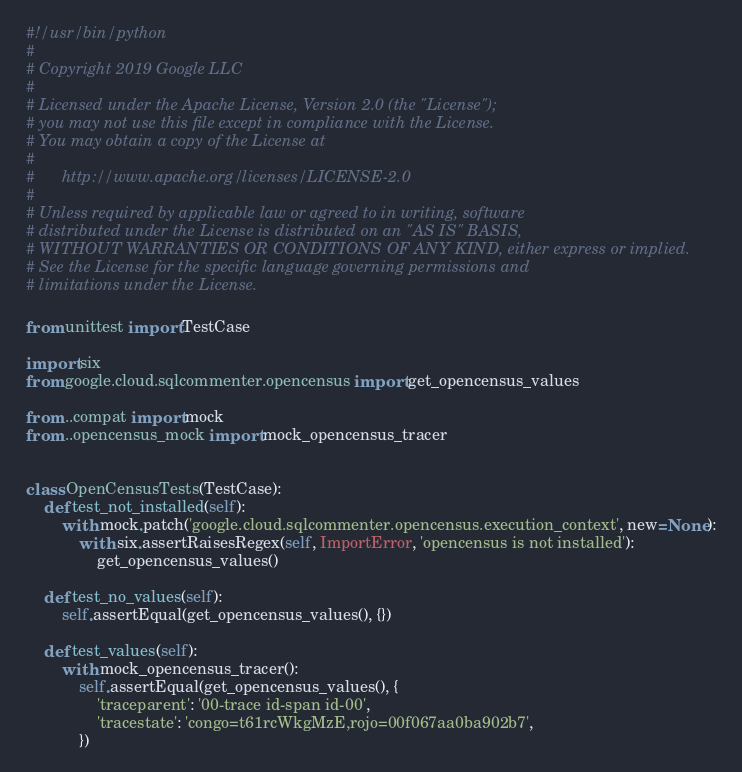<code> <loc_0><loc_0><loc_500><loc_500><_Python_>#!/usr/bin/python
#
# Copyright 2019 Google LLC
#
# Licensed under the Apache License, Version 2.0 (the "License");
# you may not use this file except in compliance with the License.
# You may obtain a copy of the License at
#
#      http://www.apache.org/licenses/LICENSE-2.0
#
# Unless required by applicable law or agreed to in writing, software
# distributed under the License is distributed on an "AS IS" BASIS,
# WITHOUT WARRANTIES OR CONDITIONS OF ANY KIND, either express or implied.
# See the License for the specific language governing permissions and
# limitations under the License.

from unittest import TestCase

import six
from google.cloud.sqlcommenter.opencensus import get_opencensus_values

from ..compat import mock
from ..opencensus_mock import mock_opencensus_tracer


class OpenCensusTests(TestCase):
    def test_not_installed(self):
        with mock.patch('google.cloud.sqlcommenter.opencensus.execution_context', new=None):
            with six.assertRaisesRegex(self, ImportError, 'opencensus is not installed'):
                get_opencensus_values()

    def test_no_values(self):
        self.assertEqual(get_opencensus_values(), {})

    def test_values(self):
        with mock_opencensus_tracer():
            self.assertEqual(get_opencensus_values(), {
                'traceparent': '00-trace id-span id-00',
                'tracestate': 'congo=t61rcWkgMzE,rojo=00f067aa0ba902b7',
            })
</code> 